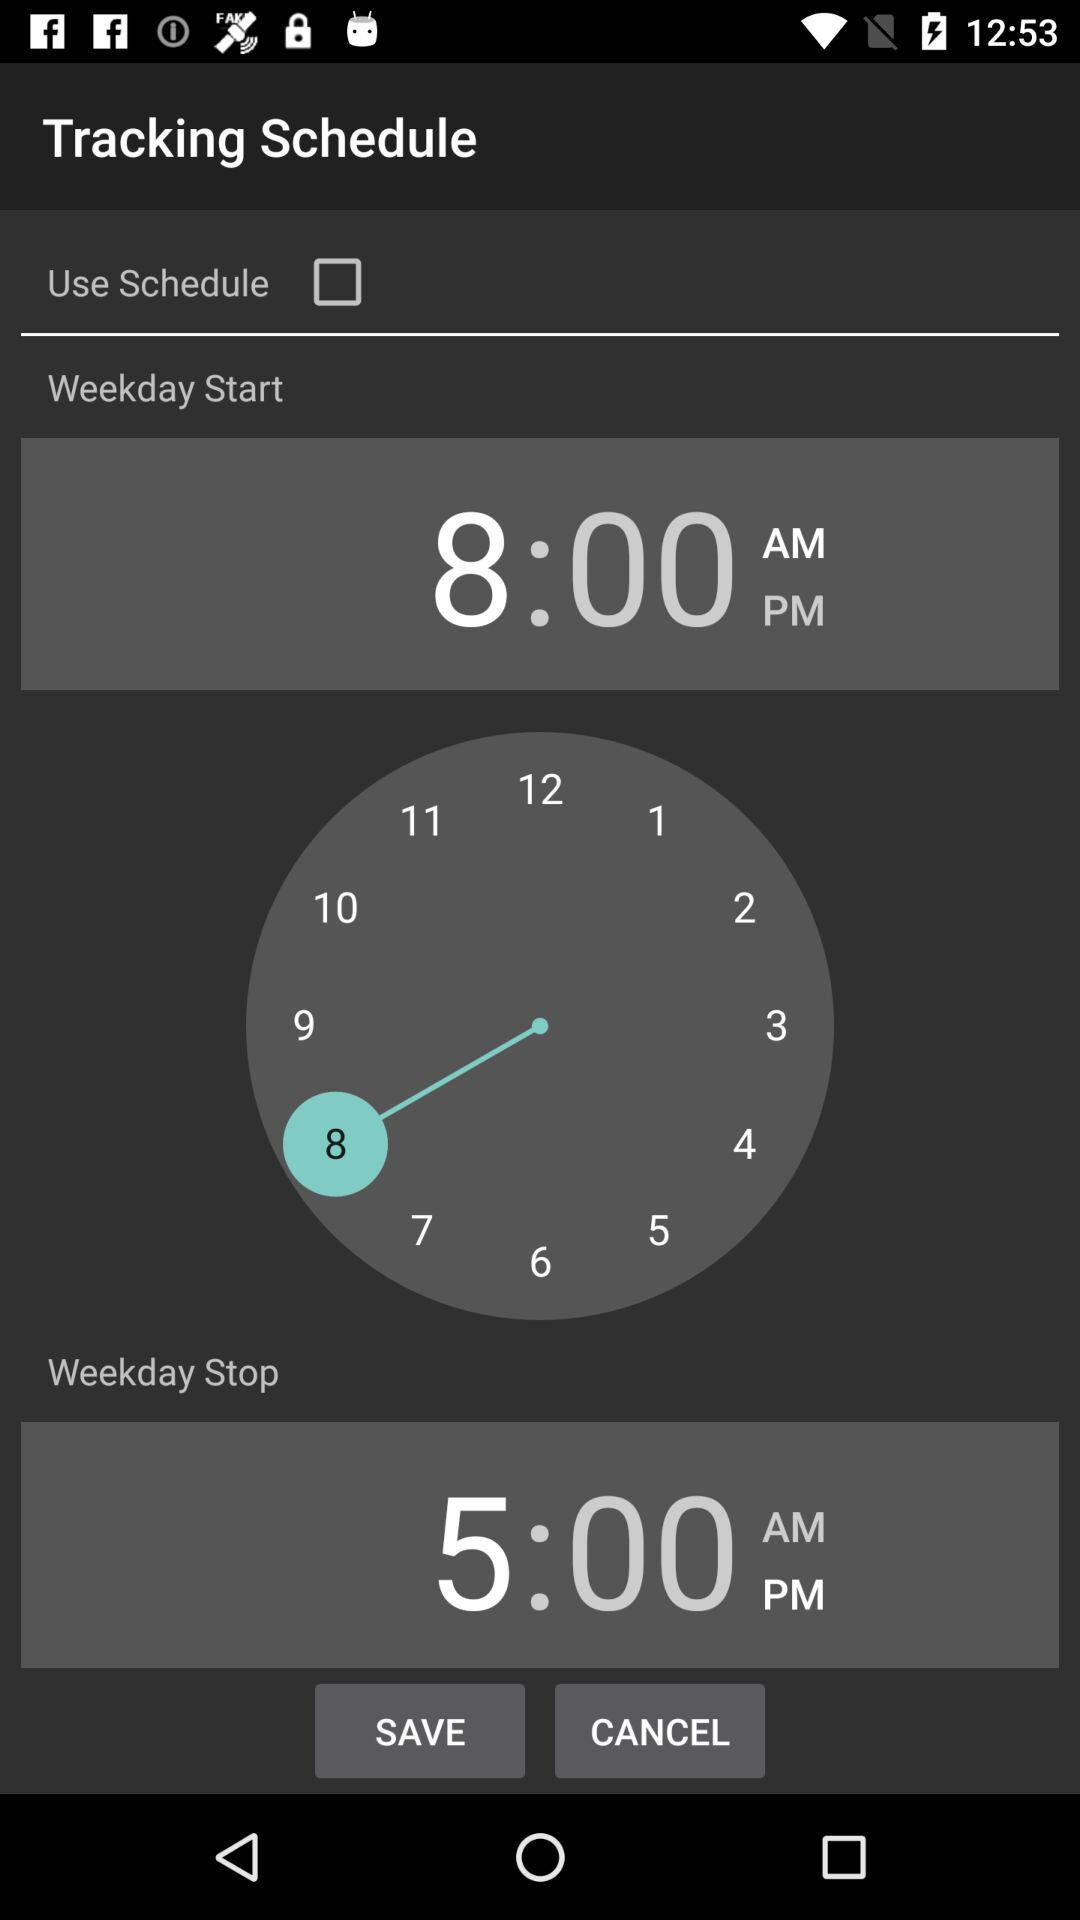Which number is highlighted on the clock? The highlighted number is 8 on the clock. 